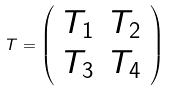Convert formula to latex. <formula><loc_0><loc_0><loc_500><loc_500>T = \left ( \begin{array} { c c } T _ { 1 } & T _ { 2 } \\ T _ { 3 } & T _ { 4 } \end{array} \right )</formula> 